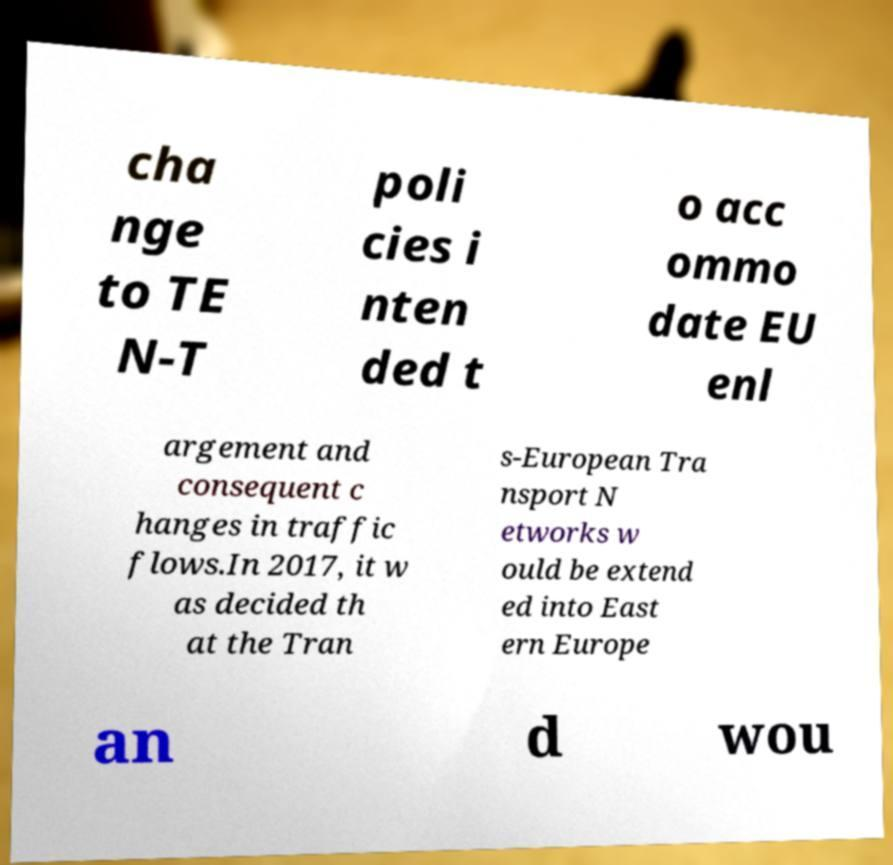What messages or text are displayed in this image? I need them in a readable, typed format. cha nge to TE N-T poli cies i nten ded t o acc ommo date EU enl argement and consequent c hanges in traffic flows.In 2017, it w as decided th at the Tran s-European Tra nsport N etworks w ould be extend ed into East ern Europe an d wou 